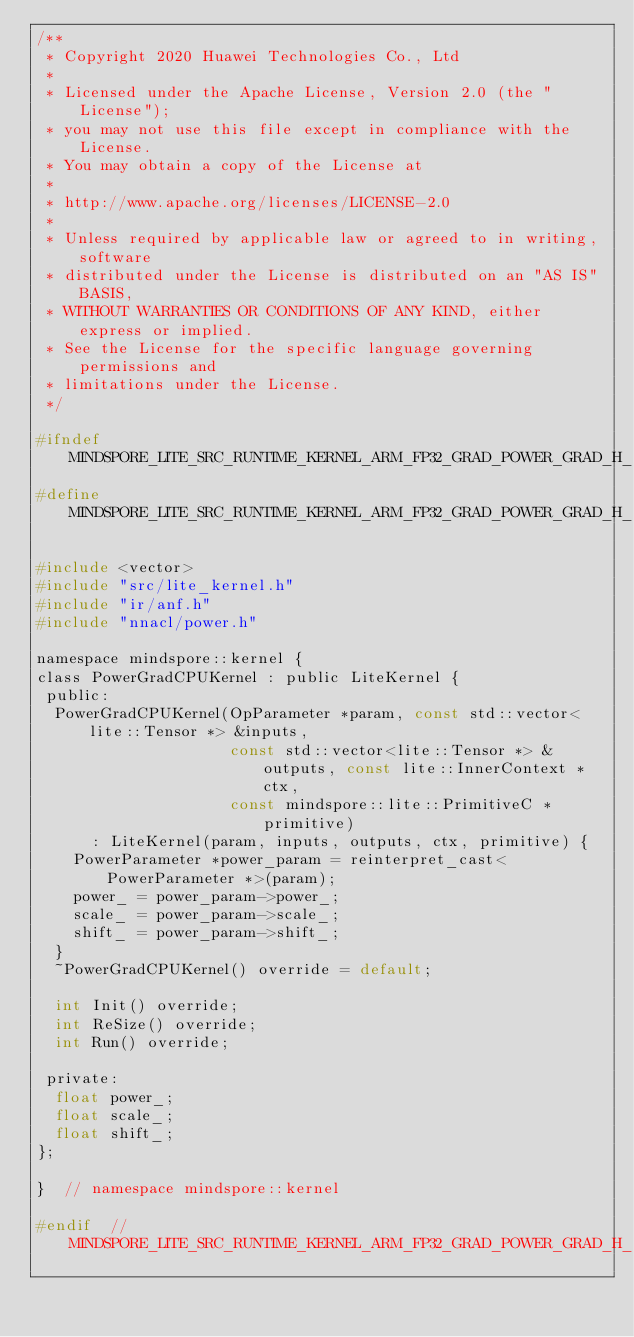<code> <loc_0><loc_0><loc_500><loc_500><_C_>/**
 * Copyright 2020 Huawei Technologies Co., Ltd
 *
 * Licensed under the Apache License, Version 2.0 (the "License");
 * you may not use this file except in compliance with the License.
 * You may obtain a copy of the License at
 *
 * http://www.apache.org/licenses/LICENSE-2.0
 *
 * Unless required by applicable law or agreed to in writing, software
 * distributed under the License is distributed on an "AS IS" BASIS,
 * WITHOUT WARRANTIES OR CONDITIONS OF ANY KIND, either express or implied.
 * See the License for the specific language governing permissions and
 * limitations under the License.
 */

#ifndef MINDSPORE_LITE_SRC_RUNTIME_KERNEL_ARM_FP32_GRAD_POWER_GRAD_H_
#define MINDSPORE_LITE_SRC_RUNTIME_KERNEL_ARM_FP32_GRAD_POWER_GRAD_H_

#include <vector>
#include "src/lite_kernel.h"
#include "ir/anf.h"
#include "nnacl/power.h"

namespace mindspore::kernel {
class PowerGradCPUKernel : public LiteKernel {
 public:
  PowerGradCPUKernel(OpParameter *param, const std::vector<lite::Tensor *> &inputs,
                     const std::vector<lite::Tensor *> &outputs, const lite::InnerContext *ctx,
                     const mindspore::lite::PrimitiveC *primitive)
      : LiteKernel(param, inputs, outputs, ctx, primitive) {
    PowerParameter *power_param = reinterpret_cast<PowerParameter *>(param);
    power_ = power_param->power_;
    scale_ = power_param->scale_;
    shift_ = power_param->shift_;
  }
  ~PowerGradCPUKernel() override = default;

  int Init() override;
  int ReSize() override;
  int Run() override;

 private:
  float power_;
  float scale_;
  float shift_;
};

}  // namespace mindspore::kernel

#endif  // MINDSPORE_LITE_SRC_RUNTIME_KERNEL_ARM_FP32_GRAD_POWER_GRAD_H_
</code> 